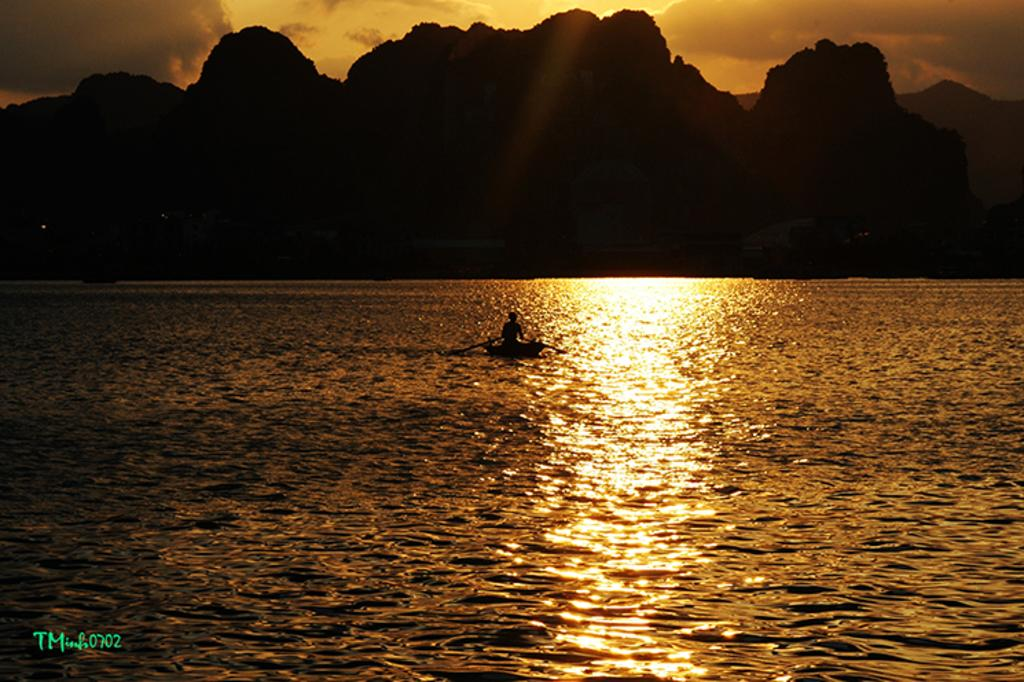What is there is a body of water visible in the image? Yes, there is water in the image. What is on the water in the image? There is a boat on the water. Who or what is on the boat? A person is sitting on the boat. What can be seen in the background of the image? There are trees, mountains, and the sky visible in the background of the image. What type of needle is being used by the band in the image? There is no band or needle present in the image. 